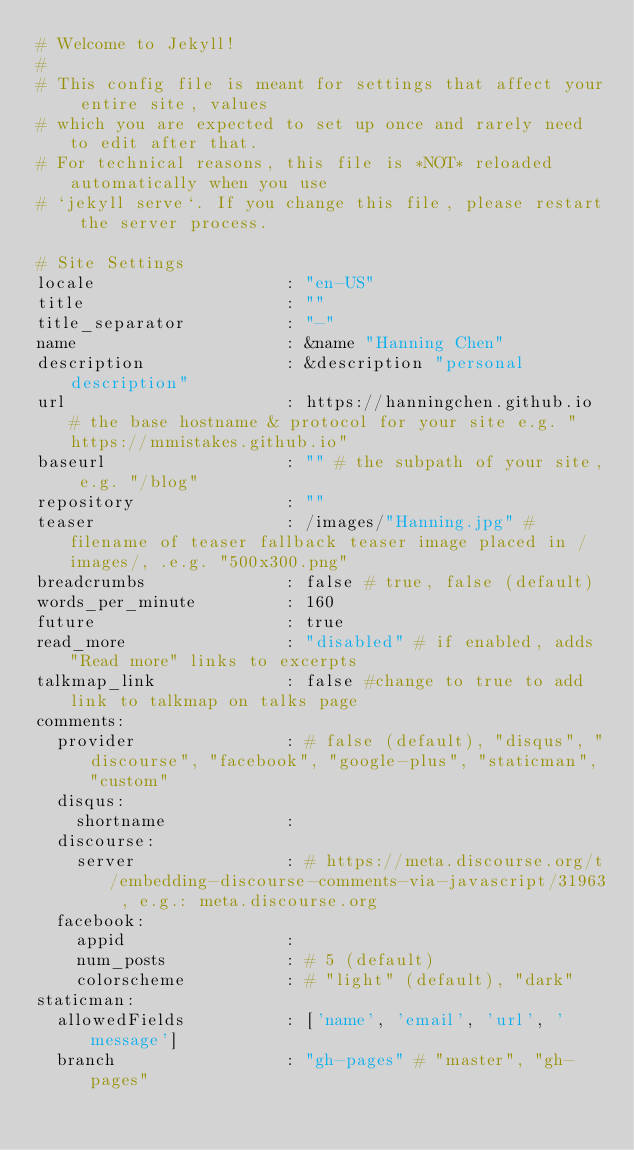<code> <loc_0><loc_0><loc_500><loc_500><_YAML_># Welcome to Jekyll!
#
# This config file is meant for settings that affect your entire site, values
# which you are expected to set up once and rarely need to edit after that.
# For technical reasons, this file is *NOT* reloaded automatically when you use
# `jekyll serve`. If you change this file, please restart the server process.

# Site Settings
locale                   : "en-US"
title                    : ""
title_separator          : "-"
name                     : &name "Hanning Chen"
description              : &description "personal description"
url                      : https://hanningchen.github.io # the base hostname & protocol for your site e.g. "https://mmistakes.github.io"
baseurl                  : "" # the subpath of your site, e.g. "/blog"
repository               : ""
teaser                   : /images/"Hanning.jpg" # filename of teaser fallback teaser image placed in /images/, .e.g. "500x300.png"
breadcrumbs              : false # true, false (default)
words_per_minute         : 160
future                   : true
read_more                : "disabled" # if enabled, adds "Read more" links to excerpts
talkmap_link             : false #change to true to add link to talkmap on talks page
comments:
  provider               : # false (default), "disqus", "discourse", "facebook", "google-plus", "staticman", "custom"
  disqus:
    shortname            :
  discourse:
    server               : # https://meta.discourse.org/t/embedding-discourse-comments-via-javascript/31963 , e.g.: meta.discourse.org
  facebook:
    appid                :
    num_posts            : # 5 (default)
    colorscheme          : # "light" (default), "dark"
staticman:
  allowedFields          : ['name', 'email', 'url', 'message']
  branch                 : "gh-pages" # "master", "gh-pages"</code> 